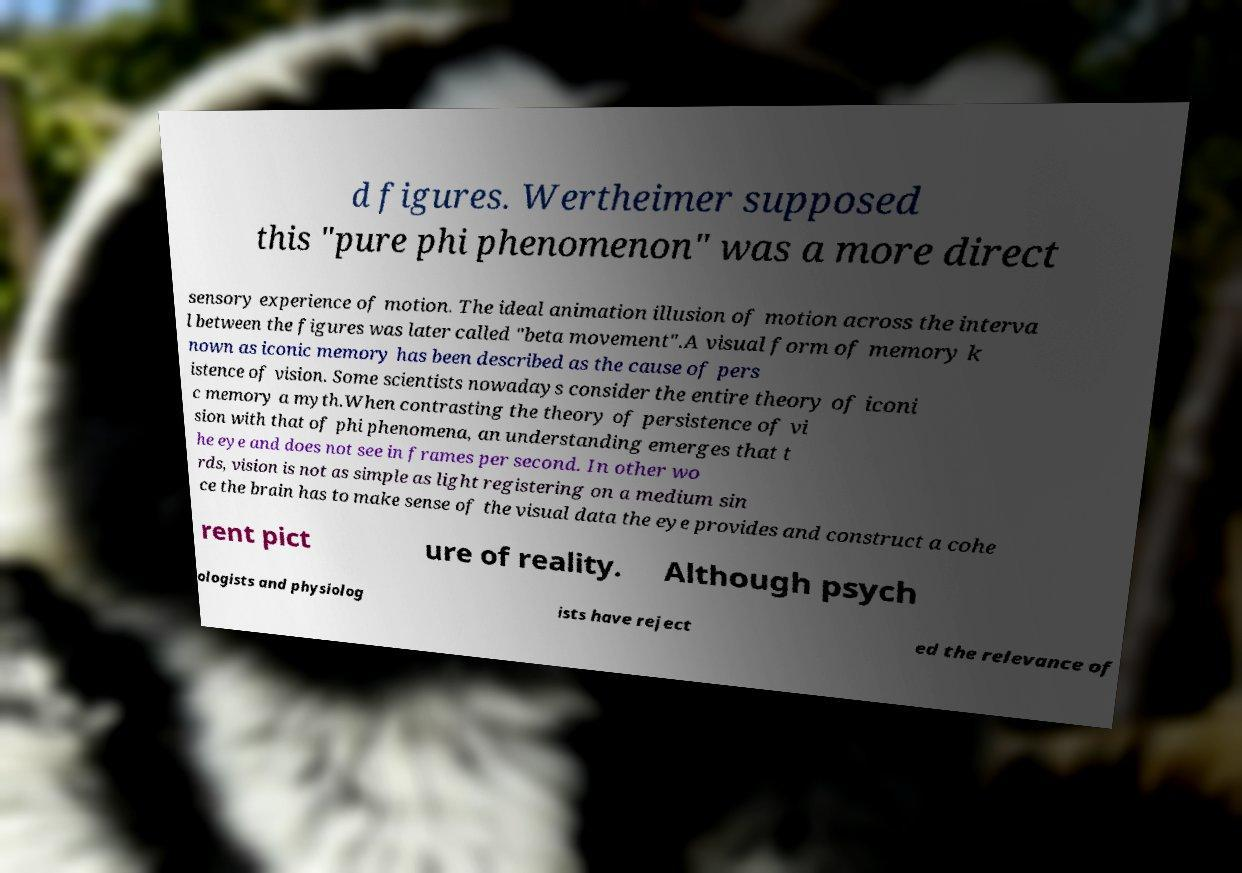Could you extract and type out the text from this image? d figures. Wertheimer supposed this "pure phi phenomenon" was a more direct sensory experience of motion. The ideal animation illusion of motion across the interva l between the figures was later called "beta movement".A visual form of memory k nown as iconic memory has been described as the cause of pers istence of vision. Some scientists nowadays consider the entire theory of iconi c memory a myth.When contrasting the theory of persistence of vi sion with that of phi phenomena, an understanding emerges that t he eye and does not see in frames per second. In other wo rds, vision is not as simple as light registering on a medium sin ce the brain has to make sense of the visual data the eye provides and construct a cohe rent pict ure of reality. Although psych ologists and physiolog ists have reject ed the relevance of 